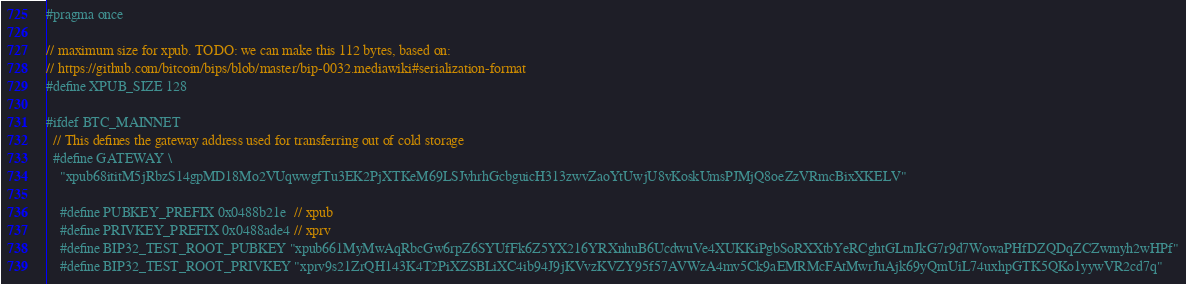Convert code to text. <code><loc_0><loc_0><loc_500><loc_500><_C_>#pragma once

// maximum size for xpub. TODO: we can make this 112 bytes, based on:
// https://github.com/bitcoin/bips/blob/master/bip-0032.mediawiki#serialization-format
#define XPUB_SIZE 128

#ifdef BTC_MAINNET
  // This defines the gateway address used for transferring out of cold storage
  #define GATEWAY \
    "xpub68ititM5jRbzS14gpMD18Mo2VUqwwgfTu3EK2PjXTKeM69LSJvhrhGcbguicH313zwvZaoYtUwjU8vKoskUmsPJMjQ8oeZzVRmcBixXKELV"

    #define PUBKEY_PREFIX 0x0488b21e  // xpub
    #define PRIVKEY_PREFIX 0x0488ade4 // xprv
    #define BIP32_TEST_ROOT_PUBKEY "xpub661MyMwAqRbcGw6rpZ6SYUfFk6Z5YX216YRXnhuB6UcdwuVe4XUKKiPgbSoRXXtbYeRCghtGLtnJkG7r9d7WowaPHfDZQDqZCZwmyh2wHPf"
    #define BIP32_TEST_ROOT_PRIVKEY "xprv9s21ZrQH143K4T2PiXZSBLiXC4ib94J9jKVvzKVZY95f57AVWzA4mv5Ck9aEMRMcFAtMwrJuAjk69yQmUiL74uxhpGTK5QKo1yywVR2cd7q"</code> 